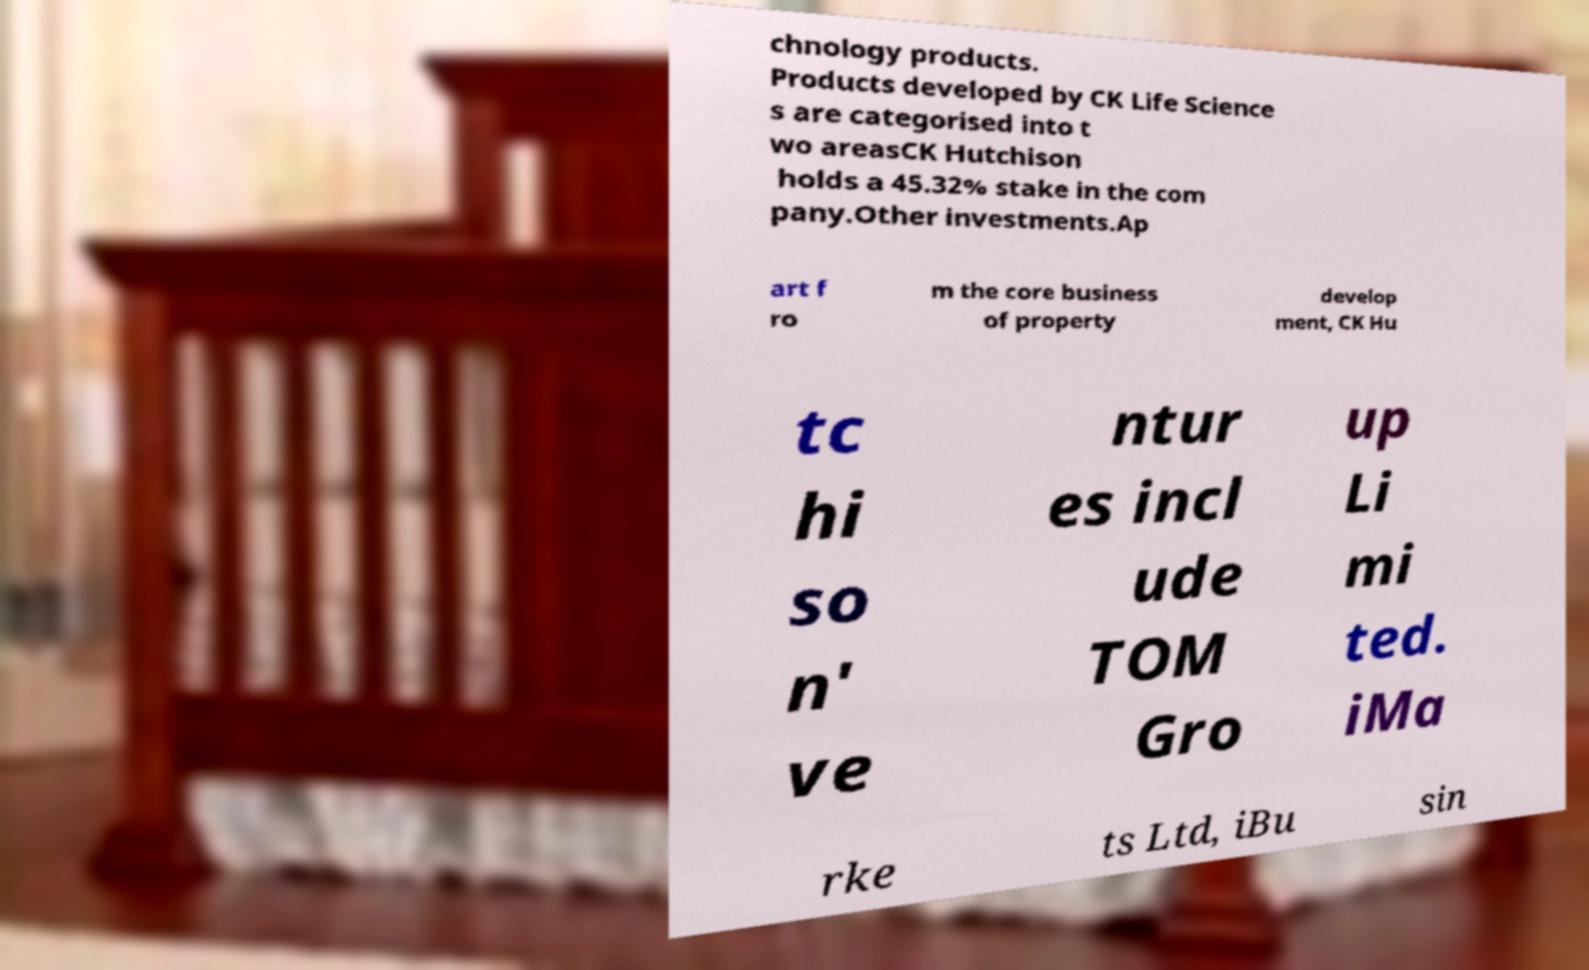Could you extract and type out the text from this image? chnology products. Products developed by CK Life Science s are categorised into t wo areasCK Hutchison holds a 45.32% stake in the com pany.Other investments.Ap art f ro m the core business of property develop ment, CK Hu tc hi so n' ve ntur es incl ude TOM Gro up Li mi ted. iMa rke ts Ltd, iBu sin 